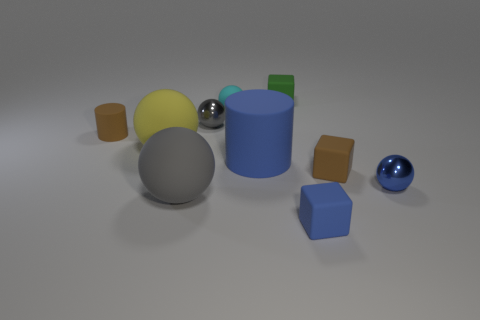There is a gray rubber object to the right of the big yellow rubber thing; does it have the same shape as the metal thing behind the tiny brown cylinder?
Your answer should be very brief. Yes. What material is the block that is the same color as the small cylinder?
Offer a very short reply. Rubber. Are there any objects?
Provide a succinct answer. Yes. There is another object that is the same shape as the large blue thing; what is it made of?
Make the answer very short. Rubber. Are there any tiny cyan balls in front of the small matte ball?
Your response must be concise. No. Are the gray thing behind the big blue object and the blue cube made of the same material?
Ensure brevity in your answer.  No. Are there any metal cylinders of the same color as the small matte ball?
Provide a short and direct response. No. The green matte object has what shape?
Offer a terse response. Cube. There is a small rubber cube in front of the tiny metallic ball that is in front of the tiny gray ball; what is its color?
Keep it short and to the point. Blue. There is a gray object behind the yellow object; what size is it?
Offer a very short reply. Small. 